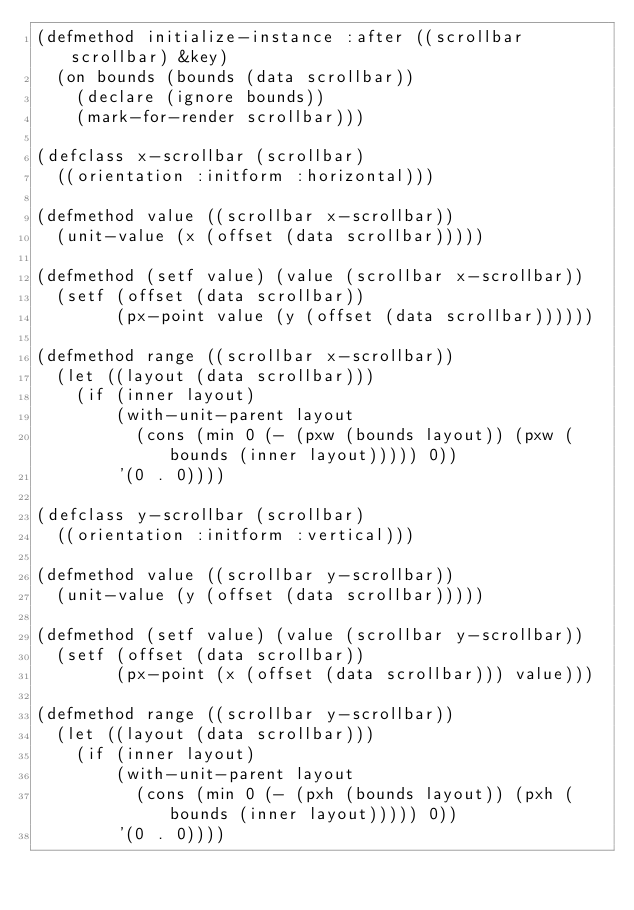Convert code to text. <code><loc_0><loc_0><loc_500><loc_500><_Lisp_>(defmethod initialize-instance :after ((scrollbar scrollbar) &key)
  (on bounds (bounds (data scrollbar))
    (declare (ignore bounds))
    (mark-for-render scrollbar)))

(defclass x-scrollbar (scrollbar)
  ((orientation :initform :horizontal)))

(defmethod value ((scrollbar x-scrollbar))
  (unit-value (x (offset (data scrollbar)))))

(defmethod (setf value) (value (scrollbar x-scrollbar))
  (setf (offset (data scrollbar))
        (px-point value (y (offset (data scrollbar))))))

(defmethod range ((scrollbar x-scrollbar))
  (let ((layout (data scrollbar)))
    (if (inner layout)
        (with-unit-parent layout
          (cons (min 0 (- (pxw (bounds layout)) (pxw (bounds (inner layout))))) 0))
        '(0 . 0))))

(defclass y-scrollbar (scrollbar)
  ((orientation :initform :vertical)))

(defmethod value ((scrollbar y-scrollbar))
  (unit-value (y (offset (data scrollbar)))))

(defmethod (setf value) (value (scrollbar y-scrollbar))
  (setf (offset (data scrollbar))
        (px-point (x (offset (data scrollbar))) value)))

(defmethod range ((scrollbar y-scrollbar))
  (let ((layout (data scrollbar)))
    (if (inner layout)
        (with-unit-parent layout
          (cons (min 0 (- (pxh (bounds layout)) (pxh (bounds (inner layout))))) 0))
        '(0 . 0))))
</code> 